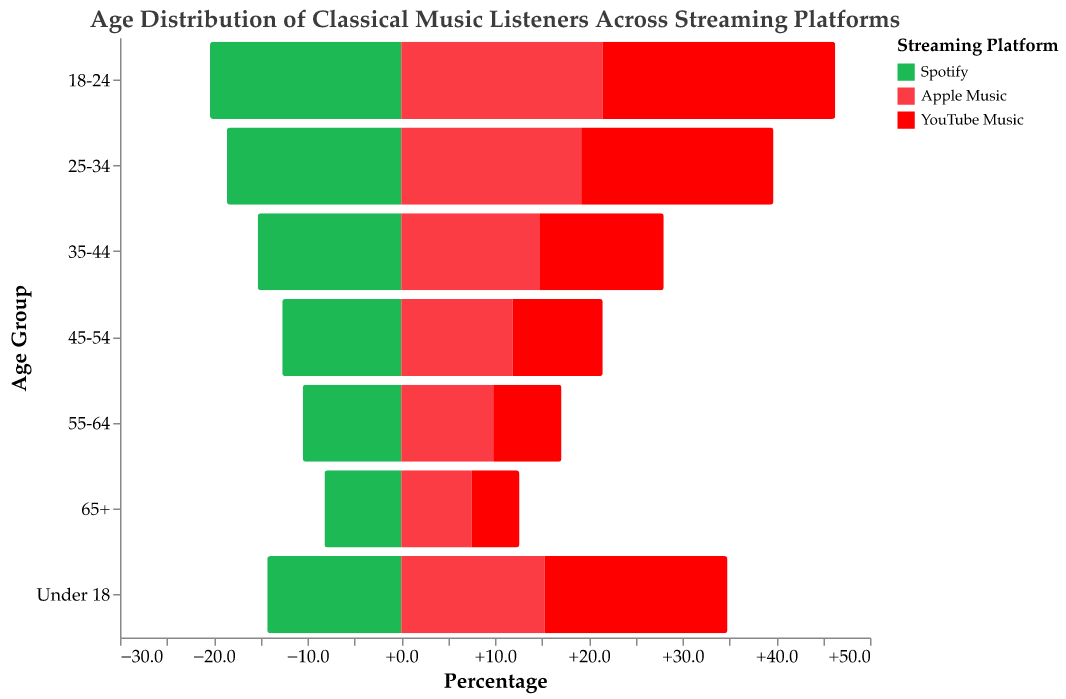What is the percentage of classical music listeners aged 18-24 using Spotify? The figure displays the percentage of classical music listeners among various age groups for different streaming platforms. For Spotify, the percentage of listeners aged 18-24 is shown as 20.4%.
Answer: 20.4% Which streaming platform has the highest percentage of listeners under 18? To determine this, compare the percentages of the 'Under 18' age group for all streaming platforms shown in the figure. YouTube Music has the highest percentage of listeners under 18 at 19.5%.
Answer: YouTube Music How does the percentage of listeners aged 55-64 on Idagio compare to that on Primephonic? Check the percentages for the 55-64 age group for both Idagio and Primephonic. Idagio has 14.6%, and Primephonic has 13.9%. Since 14.6% > 13.9%, the percentage for Idagio is higher.
Answer: Idagio has a higher percentage Which age group is the largest among classical music listeners on Apple Music? Review the percentages for each age group on Apple Music. The age group 18-24 has the highest percentage at 21.5%.
Answer: 18-24 Summing up the percentages, what is the total percentage of listeners aged 35-44 across all platforms? Add the corresponding percentages for the 35-44 age group for all platforms: Spotify (15.3), Apple Music (14.8), YouTube Music (13.2), Idagio (13.7), Primephonic (13.5). The sum is 15.3 + 14.8 + 13.2 + 13.7 + 13.5 = 70.5.
Answer: 70.5% In the 'Under 18' category, how does the percentage of listeners on Apple Music compare to those on Primephonic? For individuals under 18, the percentage on Apple Music is 15.3%, and on Primephonic, it is 8.4%. Since 15.3% > 8.4%, Apple Music has a higher percentage.
Answer: Apple Music has a higher percentage Which age group has the smallest percentage of listeners on YouTube Music? Examine the percentages for each age group on YouTube Music. The 65+ age group has the smallest percentage with 5.1%.
Answer: 65+ How do the percentages of listeners aged 45-54 on Spotify and Apple Music differ? Review the percentages for the 45-54 age group: Spotify (12.7%) and Apple Music (11.9%). The difference is 12.7% - 11.9% = 0.8%.
Answer: 0.8% What is the percentage difference between the youngest and oldest age groups for streaming classical music on Primephonic? Compare the percentages of the youngest (Under 18) and oldest (65+) age groups on Primephonic: 8.4% (Under 18) and 11.8% (65+). The difference is 11.8% - 8.4% = 3.4%.
Answer: 3.4% What is the combined percentage of classical music listeners aged 18-24 on Spotify and YouTube Music? Add the percentages of the 18-24 age group for Spotify (20.4%) and YouTube Music (24.8%). The combined percentage is 20.4% + 24.8% = 45.2%.
Answer: 45.2% 